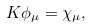<formula> <loc_0><loc_0><loc_500><loc_500>K \phi _ { \mu } = \chi _ { \mu } ,</formula> 